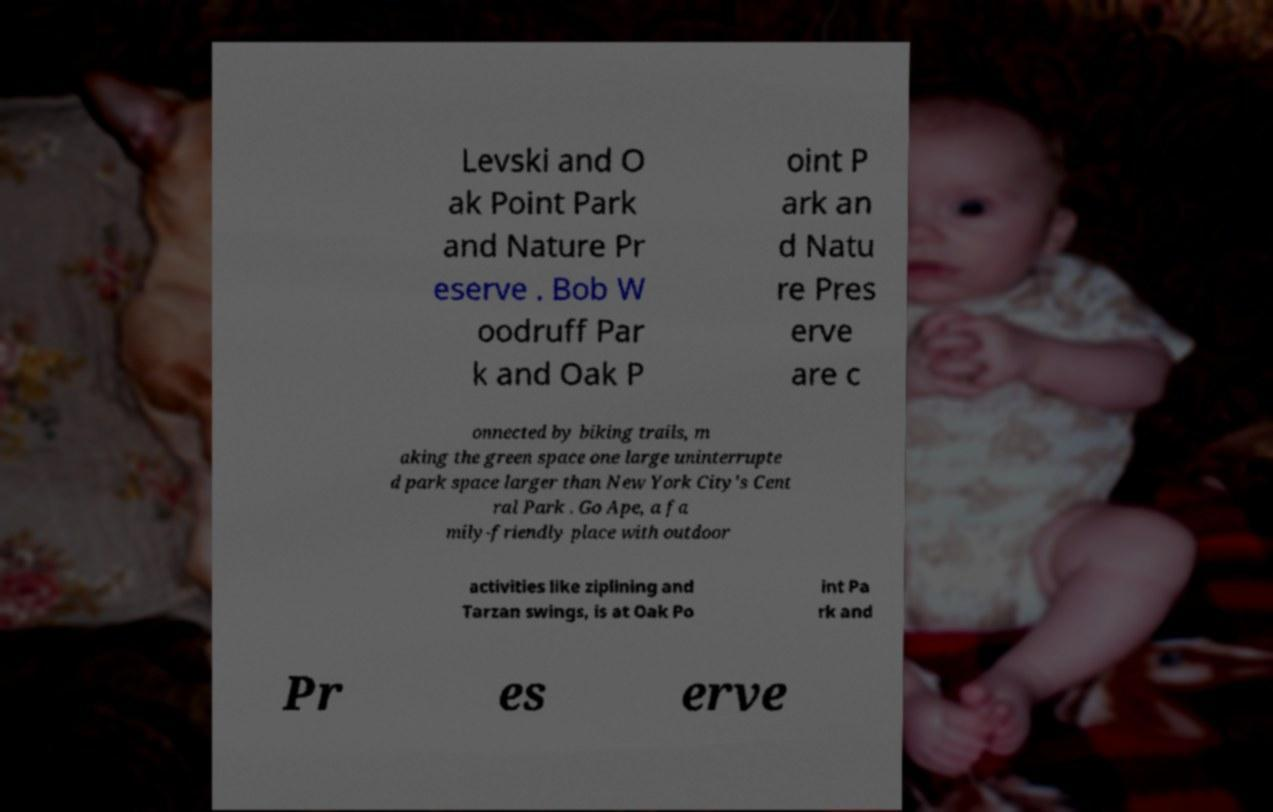Can you read and provide the text displayed in the image?This photo seems to have some interesting text. Can you extract and type it out for me? Levski and O ak Point Park and Nature Pr eserve . Bob W oodruff Par k and Oak P oint P ark an d Natu re Pres erve are c onnected by biking trails, m aking the green space one large uninterrupte d park space larger than New York City's Cent ral Park . Go Ape, a fa mily-friendly place with outdoor activities like ziplining and Tarzan swings, is at Oak Po int Pa rk and Pr es erve 